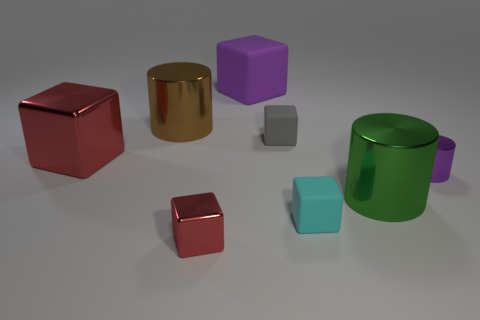Subtract all red shiny cubes. How many cubes are left? 3 Subtract 3 blocks. How many blocks are left? 2 Subtract all purple blocks. How many blocks are left? 4 Add 1 purple metallic objects. How many objects exist? 9 Subtract all cylinders. How many objects are left? 5 Subtract all purple blocks. Subtract all brown spheres. How many blocks are left? 4 Subtract all yellow cubes. Subtract all brown cylinders. How many objects are left? 7 Add 2 gray cubes. How many gray cubes are left? 3 Add 5 purple blocks. How many purple blocks exist? 6 Subtract 0 green balls. How many objects are left? 8 